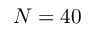Convert formula to latex. <formula><loc_0><loc_0><loc_500><loc_500>N = 4 0</formula> 